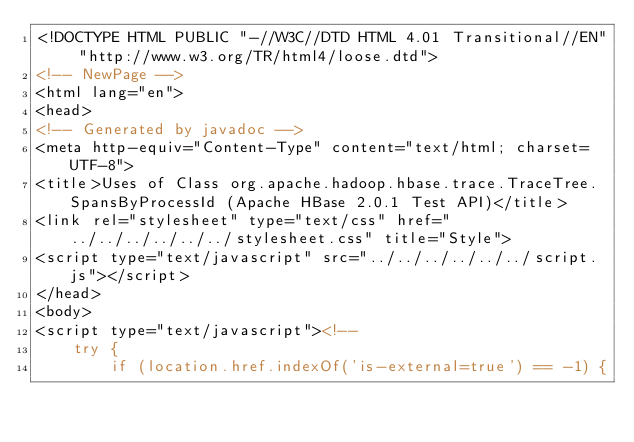Convert code to text. <code><loc_0><loc_0><loc_500><loc_500><_HTML_><!DOCTYPE HTML PUBLIC "-//W3C//DTD HTML 4.01 Transitional//EN" "http://www.w3.org/TR/html4/loose.dtd">
<!-- NewPage -->
<html lang="en">
<head>
<!-- Generated by javadoc -->
<meta http-equiv="Content-Type" content="text/html; charset=UTF-8">
<title>Uses of Class org.apache.hadoop.hbase.trace.TraceTree.SpansByProcessId (Apache HBase 2.0.1 Test API)</title>
<link rel="stylesheet" type="text/css" href="../../../../../../stylesheet.css" title="Style">
<script type="text/javascript" src="../../../../../../script.js"></script>
</head>
<body>
<script type="text/javascript"><!--
    try {
        if (location.href.indexOf('is-external=true') == -1) {</code> 